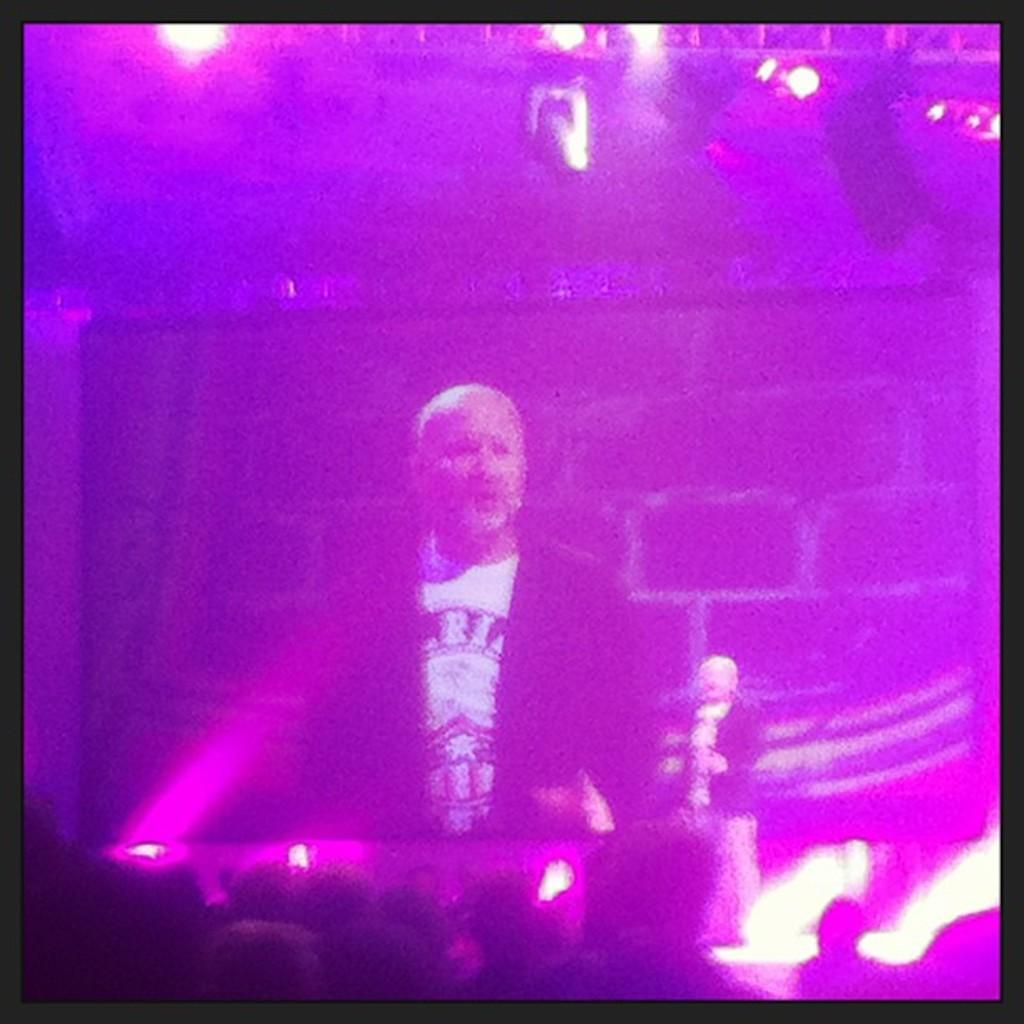What is the main subject of the image? There is a person standing in the image. What is the person wearing? The person is wearing a white shirt. What additional elements can be seen in the image? There are colorful lights visible in the image. How many passengers are sitting in the camp in the image? There is no camp or passengers present in the image; it features a person standing and colorful lights. 